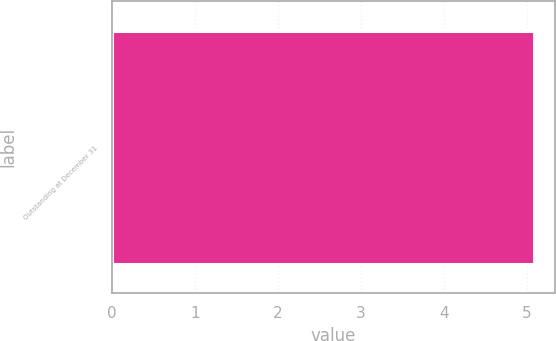Convert chart to OTSL. <chart><loc_0><loc_0><loc_500><loc_500><bar_chart><fcel>Outstanding at December 31<nl><fcel>5.08<nl></chart> 